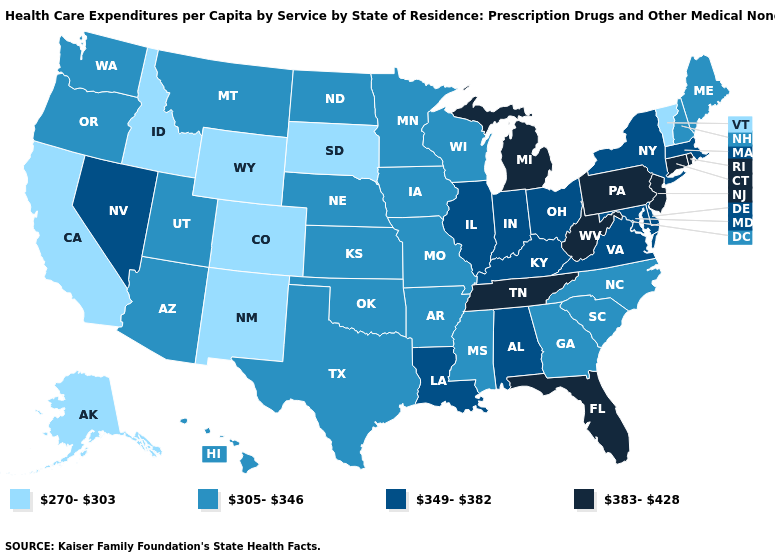Name the states that have a value in the range 383-428?
Be succinct. Connecticut, Florida, Michigan, New Jersey, Pennsylvania, Rhode Island, Tennessee, West Virginia. What is the highest value in states that border Ohio?
Keep it brief. 383-428. What is the highest value in states that border California?
Concise answer only. 349-382. Name the states that have a value in the range 270-303?
Write a very short answer. Alaska, California, Colorado, Idaho, New Mexico, South Dakota, Vermont, Wyoming. What is the lowest value in the Northeast?
Be succinct. 270-303. Does Oregon have the lowest value in the USA?
Give a very brief answer. No. What is the lowest value in the USA?
Quick response, please. 270-303. What is the value of Utah?
Give a very brief answer. 305-346. What is the lowest value in the MidWest?
Concise answer only. 270-303. Does Pennsylvania have a higher value than Louisiana?
Answer briefly. Yes. What is the highest value in the West ?
Concise answer only. 349-382. What is the highest value in states that border Maryland?
Give a very brief answer. 383-428. What is the value of Minnesota?
Give a very brief answer. 305-346. What is the value of Colorado?
Quick response, please. 270-303. Name the states that have a value in the range 305-346?
Be succinct. Arizona, Arkansas, Georgia, Hawaii, Iowa, Kansas, Maine, Minnesota, Mississippi, Missouri, Montana, Nebraska, New Hampshire, North Carolina, North Dakota, Oklahoma, Oregon, South Carolina, Texas, Utah, Washington, Wisconsin. 